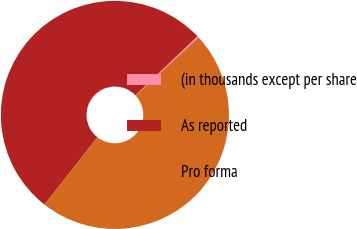Convert chart to OTSL. <chart><loc_0><loc_0><loc_500><loc_500><pie_chart><fcel>(in thousands except per share<fcel>As reported<fcel>Pro forma<nl><fcel>0.22%<fcel>52.31%<fcel>47.47%<nl></chart> 